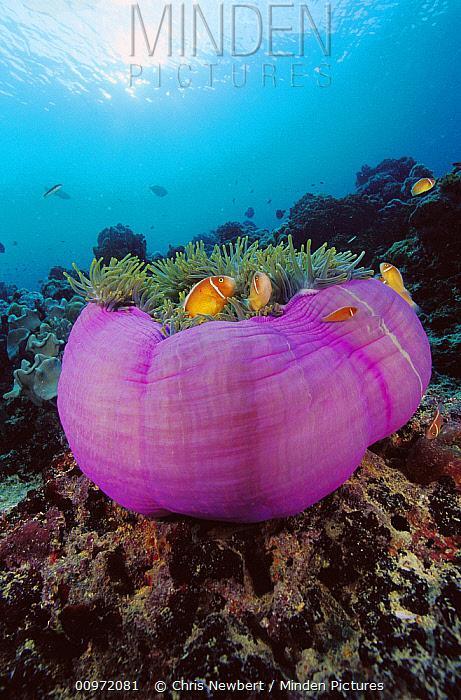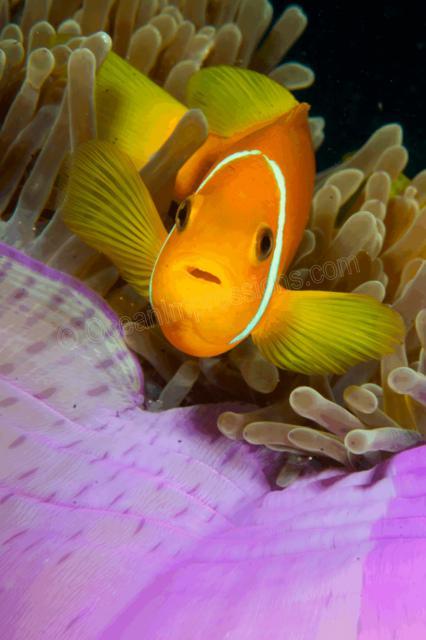The first image is the image on the left, the second image is the image on the right. Given the left and right images, does the statement "Right image shows a lavender anemone with plush-looking folds." hold true? Answer yes or no. No. The first image is the image on the left, the second image is the image on the right. Given the left and right images, does the statement "Only one of the images has a fish in it." hold true? Answer yes or no. No. 